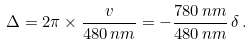Convert formula to latex. <formula><loc_0><loc_0><loc_500><loc_500>\Delta = 2 \pi \times \frac { v } { 4 8 0 \, n m } = - \frac { 7 8 0 \, n m } { 4 8 0 \, n m } \, \delta \, .</formula> 